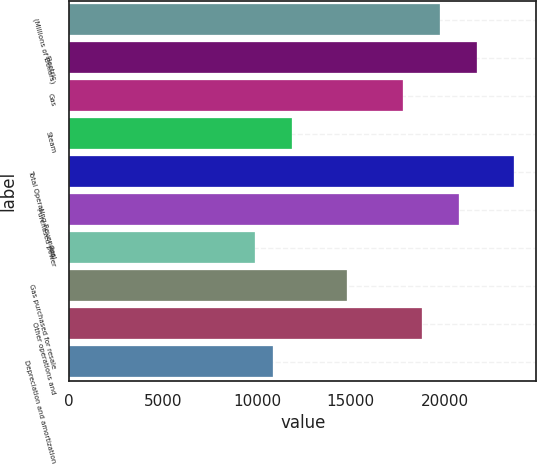Convert chart to OTSL. <chart><loc_0><loc_0><loc_500><loc_500><bar_chart><fcel>(Millions of Dollars)<fcel>Electric<fcel>Gas<fcel>Steam<fcel>Total Operating Revenues<fcel>Purchased power<fcel>Fuel<fcel>Gas purchased for resale<fcel>Other operations and<fcel>Depreciation and amortization<nl><fcel>19763<fcel>21738.6<fcel>17787.4<fcel>11860.6<fcel>23714.2<fcel>20750.8<fcel>9885<fcel>14824<fcel>18775.2<fcel>10872.8<nl></chart> 